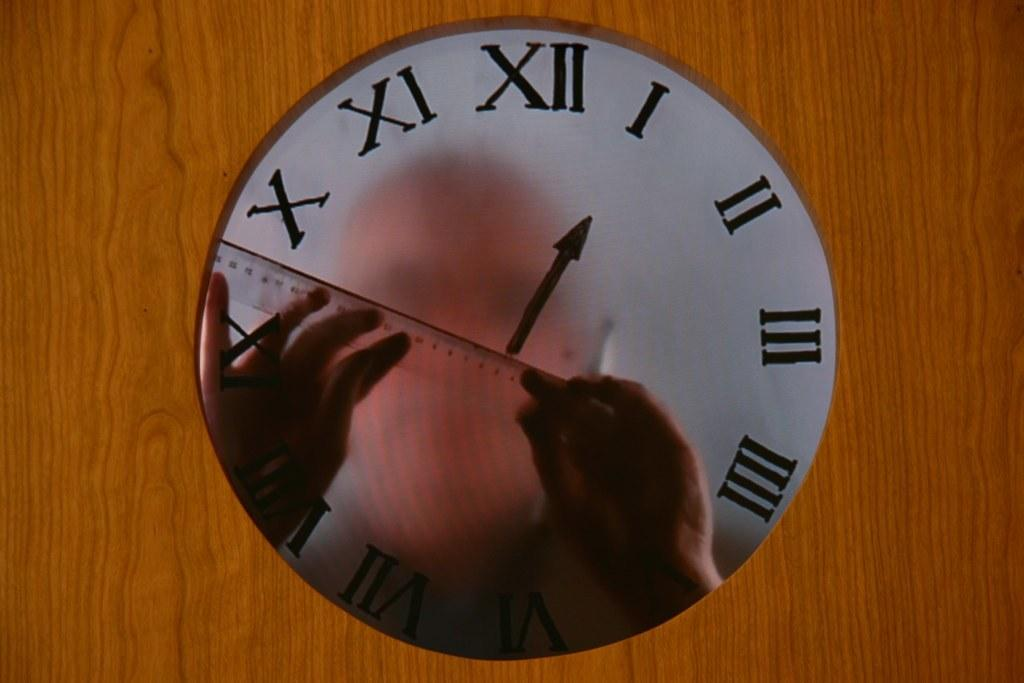<image>
Describe the image concisely. A mirror clock that shows a man holding a ruler points to the number I 